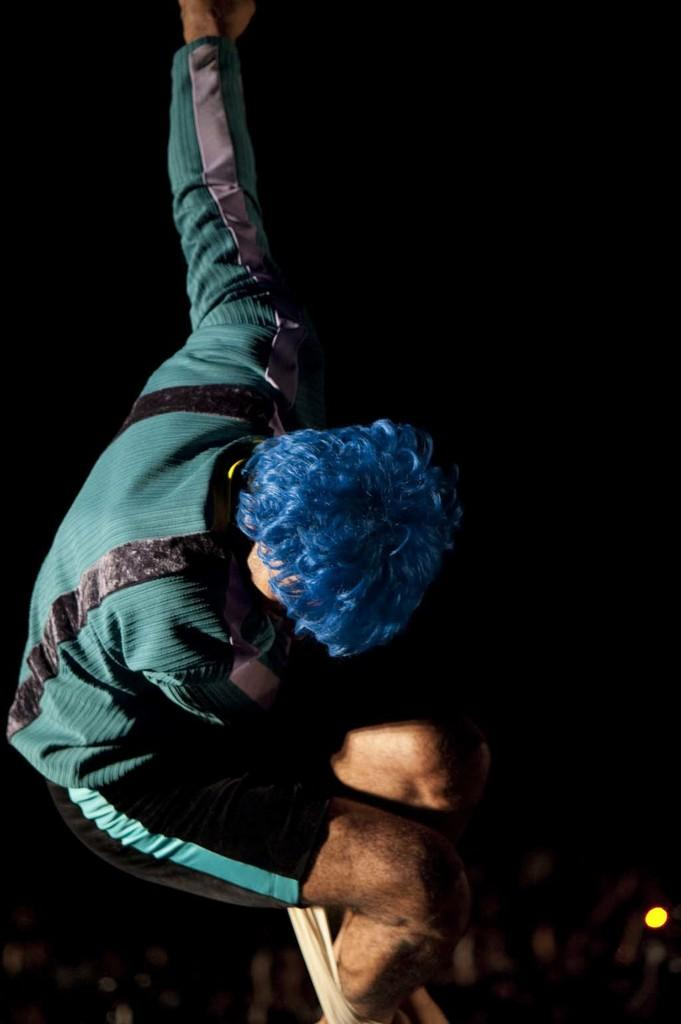What is the main subject of the image? There is a person in the image. What is the person doing in the image? The person is on a rope. Where is the person located in the image? The person is in the center of the image. How many cherries are being brushed by the toothbrush in the image? There are no cherries or toothbrushes present in the image. 